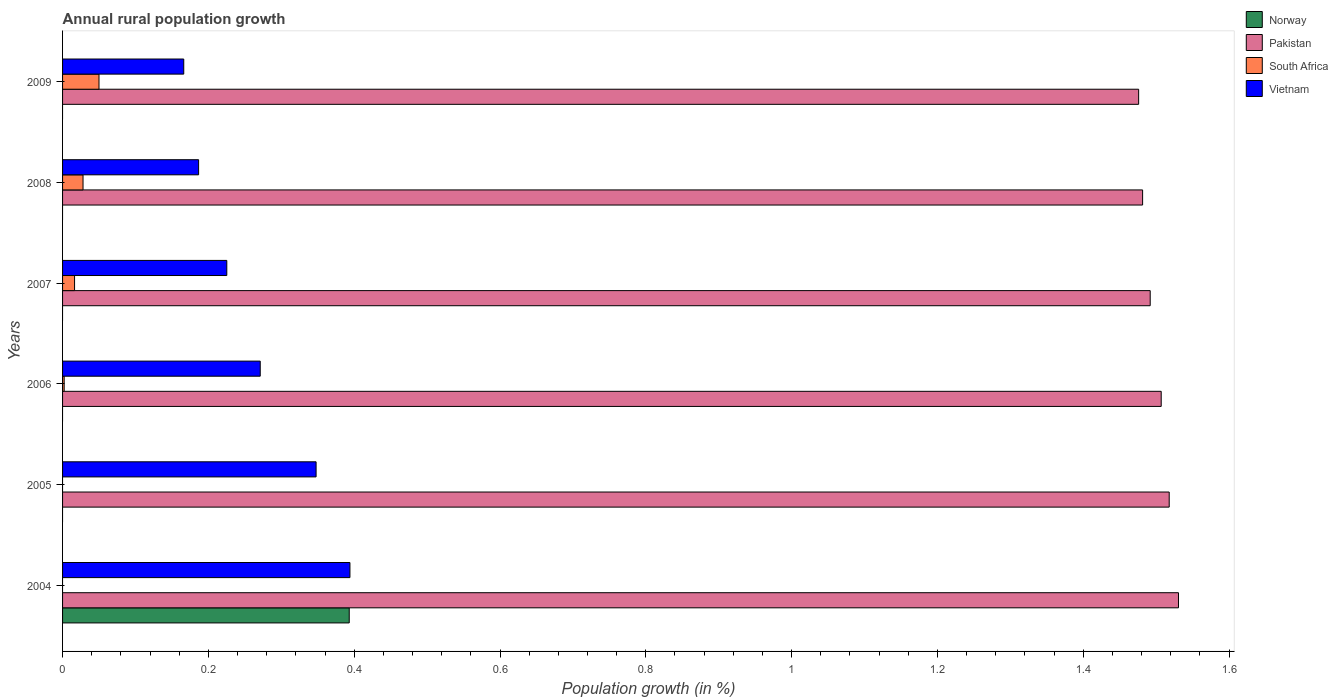How many different coloured bars are there?
Ensure brevity in your answer.  4. Are the number of bars per tick equal to the number of legend labels?
Offer a terse response. No. Are the number of bars on each tick of the Y-axis equal?
Your answer should be compact. No. How many bars are there on the 1st tick from the top?
Your answer should be very brief. 3. How many bars are there on the 6th tick from the bottom?
Your answer should be very brief. 3. What is the label of the 3rd group of bars from the top?
Your answer should be very brief. 2007. What is the percentage of rural population growth in Pakistan in 2006?
Keep it short and to the point. 1.51. Across all years, what is the maximum percentage of rural population growth in South Africa?
Provide a succinct answer. 0.05. In which year was the percentage of rural population growth in Norway maximum?
Offer a terse response. 2004. What is the total percentage of rural population growth in South Africa in the graph?
Ensure brevity in your answer.  0.1. What is the difference between the percentage of rural population growth in Vietnam in 2006 and that in 2009?
Provide a short and direct response. 0.1. What is the difference between the percentage of rural population growth in South Africa in 2006 and the percentage of rural population growth in Pakistan in 2009?
Give a very brief answer. -1.47. What is the average percentage of rural population growth in Vietnam per year?
Your answer should be compact. 0.27. In the year 2007, what is the difference between the percentage of rural population growth in Pakistan and percentage of rural population growth in Vietnam?
Your answer should be very brief. 1.27. In how many years, is the percentage of rural population growth in Pakistan greater than 1.36 %?
Keep it short and to the point. 6. What is the ratio of the percentage of rural population growth in Vietnam in 2005 to that in 2006?
Provide a short and direct response. 1.28. What is the difference between the highest and the second highest percentage of rural population growth in Vietnam?
Your response must be concise. 0.05. What is the difference between the highest and the lowest percentage of rural population growth in Pakistan?
Provide a short and direct response. 0.05. Is it the case that in every year, the sum of the percentage of rural population growth in Norway and percentage of rural population growth in Vietnam is greater than the sum of percentage of rural population growth in Pakistan and percentage of rural population growth in South Africa?
Provide a short and direct response. No. Is it the case that in every year, the sum of the percentage of rural population growth in Pakistan and percentage of rural population growth in Vietnam is greater than the percentage of rural population growth in South Africa?
Provide a succinct answer. Yes. How many bars are there?
Your answer should be very brief. 17. Are all the bars in the graph horizontal?
Ensure brevity in your answer.  Yes. How many years are there in the graph?
Offer a terse response. 6. What is the difference between two consecutive major ticks on the X-axis?
Your answer should be very brief. 0.2. Where does the legend appear in the graph?
Provide a succinct answer. Top right. What is the title of the graph?
Offer a terse response. Annual rural population growth. What is the label or title of the X-axis?
Offer a terse response. Population growth (in %). What is the Population growth (in %) in Norway in 2004?
Your response must be concise. 0.39. What is the Population growth (in %) in Pakistan in 2004?
Your answer should be very brief. 1.53. What is the Population growth (in %) of South Africa in 2004?
Keep it short and to the point. 0. What is the Population growth (in %) in Vietnam in 2004?
Your answer should be very brief. 0.39. What is the Population growth (in %) in Norway in 2005?
Offer a terse response. 0. What is the Population growth (in %) in Pakistan in 2005?
Ensure brevity in your answer.  1.52. What is the Population growth (in %) in Vietnam in 2005?
Make the answer very short. 0.35. What is the Population growth (in %) in Norway in 2006?
Make the answer very short. 0. What is the Population growth (in %) of Pakistan in 2006?
Make the answer very short. 1.51. What is the Population growth (in %) of South Africa in 2006?
Offer a terse response. 0. What is the Population growth (in %) in Vietnam in 2006?
Give a very brief answer. 0.27. What is the Population growth (in %) in Norway in 2007?
Your answer should be compact. 0. What is the Population growth (in %) in Pakistan in 2007?
Offer a terse response. 1.49. What is the Population growth (in %) of South Africa in 2007?
Your answer should be compact. 0.02. What is the Population growth (in %) of Vietnam in 2007?
Ensure brevity in your answer.  0.23. What is the Population growth (in %) of Norway in 2008?
Your response must be concise. 0. What is the Population growth (in %) of Pakistan in 2008?
Keep it short and to the point. 1.48. What is the Population growth (in %) of South Africa in 2008?
Provide a succinct answer. 0.03. What is the Population growth (in %) in Vietnam in 2008?
Your answer should be very brief. 0.19. What is the Population growth (in %) in Pakistan in 2009?
Provide a short and direct response. 1.48. What is the Population growth (in %) of South Africa in 2009?
Provide a succinct answer. 0.05. What is the Population growth (in %) of Vietnam in 2009?
Ensure brevity in your answer.  0.17. Across all years, what is the maximum Population growth (in %) of Norway?
Your answer should be very brief. 0.39. Across all years, what is the maximum Population growth (in %) in Pakistan?
Your answer should be compact. 1.53. Across all years, what is the maximum Population growth (in %) in South Africa?
Ensure brevity in your answer.  0.05. Across all years, what is the maximum Population growth (in %) of Vietnam?
Your response must be concise. 0.39. Across all years, what is the minimum Population growth (in %) in Norway?
Make the answer very short. 0. Across all years, what is the minimum Population growth (in %) of Pakistan?
Keep it short and to the point. 1.48. Across all years, what is the minimum Population growth (in %) of Vietnam?
Give a very brief answer. 0.17. What is the total Population growth (in %) of Norway in the graph?
Your answer should be compact. 0.39. What is the total Population growth (in %) of Pakistan in the graph?
Provide a succinct answer. 9. What is the total Population growth (in %) of South Africa in the graph?
Your answer should be compact. 0.1. What is the total Population growth (in %) of Vietnam in the graph?
Offer a very short reply. 1.59. What is the difference between the Population growth (in %) of Pakistan in 2004 and that in 2005?
Make the answer very short. 0.01. What is the difference between the Population growth (in %) of Vietnam in 2004 and that in 2005?
Your response must be concise. 0.05. What is the difference between the Population growth (in %) of Pakistan in 2004 and that in 2006?
Ensure brevity in your answer.  0.02. What is the difference between the Population growth (in %) of Vietnam in 2004 and that in 2006?
Your answer should be compact. 0.12. What is the difference between the Population growth (in %) in Pakistan in 2004 and that in 2007?
Your answer should be very brief. 0.04. What is the difference between the Population growth (in %) of Vietnam in 2004 and that in 2007?
Provide a succinct answer. 0.17. What is the difference between the Population growth (in %) in Pakistan in 2004 and that in 2008?
Provide a succinct answer. 0.05. What is the difference between the Population growth (in %) in Vietnam in 2004 and that in 2008?
Your response must be concise. 0.21. What is the difference between the Population growth (in %) of Pakistan in 2004 and that in 2009?
Keep it short and to the point. 0.05. What is the difference between the Population growth (in %) in Vietnam in 2004 and that in 2009?
Provide a succinct answer. 0.23. What is the difference between the Population growth (in %) in Pakistan in 2005 and that in 2006?
Keep it short and to the point. 0.01. What is the difference between the Population growth (in %) of Vietnam in 2005 and that in 2006?
Your answer should be very brief. 0.08. What is the difference between the Population growth (in %) in Pakistan in 2005 and that in 2007?
Provide a short and direct response. 0.03. What is the difference between the Population growth (in %) of Vietnam in 2005 and that in 2007?
Ensure brevity in your answer.  0.12. What is the difference between the Population growth (in %) of Pakistan in 2005 and that in 2008?
Ensure brevity in your answer.  0.04. What is the difference between the Population growth (in %) in Vietnam in 2005 and that in 2008?
Your response must be concise. 0.16. What is the difference between the Population growth (in %) of Pakistan in 2005 and that in 2009?
Offer a very short reply. 0.04. What is the difference between the Population growth (in %) in Vietnam in 2005 and that in 2009?
Offer a very short reply. 0.18. What is the difference between the Population growth (in %) of Pakistan in 2006 and that in 2007?
Give a very brief answer. 0.02. What is the difference between the Population growth (in %) in South Africa in 2006 and that in 2007?
Ensure brevity in your answer.  -0.01. What is the difference between the Population growth (in %) of Vietnam in 2006 and that in 2007?
Give a very brief answer. 0.05. What is the difference between the Population growth (in %) in Pakistan in 2006 and that in 2008?
Give a very brief answer. 0.03. What is the difference between the Population growth (in %) of South Africa in 2006 and that in 2008?
Your answer should be compact. -0.03. What is the difference between the Population growth (in %) in Vietnam in 2006 and that in 2008?
Your response must be concise. 0.08. What is the difference between the Population growth (in %) of Pakistan in 2006 and that in 2009?
Your answer should be very brief. 0.03. What is the difference between the Population growth (in %) of South Africa in 2006 and that in 2009?
Ensure brevity in your answer.  -0.05. What is the difference between the Population growth (in %) in Vietnam in 2006 and that in 2009?
Make the answer very short. 0.1. What is the difference between the Population growth (in %) of Pakistan in 2007 and that in 2008?
Offer a terse response. 0.01. What is the difference between the Population growth (in %) of South Africa in 2007 and that in 2008?
Provide a succinct answer. -0.01. What is the difference between the Population growth (in %) of Vietnam in 2007 and that in 2008?
Make the answer very short. 0.04. What is the difference between the Population growth (in %) in Pakistan in 2007 and that in 2009?
Your answer should be very brief. 0.02. What is the difference between the Population growth (in %) of South Africa in 2007 and that in 2009?
Your answer should be compact. -0.03. What is the difference between the Population growth (in %) of Vietnam in 2007 and that in 2009?
Ensure brevity in your answer.  0.06. What is the difference between the Population growth (in %) of Pakistan in 2008 and that in 2009?
Offer a terse response. 0.01. What is the difference between the Population growth (in %) in South Africa in 2008 and that in 2009?
Provide a succinct answer. -0.02. What is the difference between the Population growth (in %) of Vietnam in 2008 and that in 2009?
Make the answer very short. 0.02. What is the difference between the Population growth (in %) of Norway in 2004 and the Population growth (in %) of Pakistan in 2005?
Keep it short and to the point. -1.12. What is the difference between the Population growth (in %) of Norway in 2004 and the Population growth (in %) of Vietnam in 2005?
Your answer should be compact. 0.05. What is the difference between the Population growth (in %) of Pakistan in 2004 and the Population growth (in %) of Vietnam in 2005?
Ensure brevity in your answer.  1.18. What is the difference between the Population growth (in %) of Norway in 2004 and the Population growth (in %) of Pakistan in 2006?
Give a very brief answer. -1.11. What is the difference between the Population growth (in %) of Norway in 2004 and the Population growth (in %) of South Africa in 2006?
Ensure brevity in your answer.  0.39. What is the difference between the Population growth (in %) of Norway in 2004 and the Population growth (in %) of Vietnam in 2006?
Provide a succinct answer. 0.12. What is the difference between the Population growth (in %) of Pakistan in 2004 and the Population growth (in %) of South Africa in 2006?
Make the answer very short. 1.53. What is the difference between the Population growth (in %) in Pakistan in 2004 and the Population growth (in %) in Vietnam in 2006?
Your answer should be very brief. 1.26. What is the difference between the Population growth (in %) of Norway in 2004 and the Population growth (in %) of Pakistan in 2007?
Offer a terse response. -1.1. What is the difference between the Population growth (in %) in Norway in 2004 and the Population growth (in %) in South Africa in 2007?
Offer a very short reply. 0.38. What is the difference between the Population growth (in %) in Norway in 2004 and the Population growth (in %) in Vietnam in 2007?
Offer a very short reply. 0.17. What is the difference between the Population growth (in %) of Pakistan in 2004 and the Population growth (in %) of South Africa in 2007?
Ensure brevity in your answer.  1.51. What is the difference between the Population growth (in %) in Pakistan in 2004 and the Population growth (in %) in Vietnam in 2007?
Ensure brevity in your answer.  1.31. What is the difference between the Population growth (in %) in Norway in 2004 and the Population growth (in %) in Pakistan in 2008?
Offer a terse response. -1.09. What is the difference between the Population growth (in %) in Norway in 2004 and the Population growth (in %) in South Africa in 2008?
Your answer should be compact. 0.37. What is the difference between the Population growth (in %) of Norway in 2004 and the Population growth (in %) of Vietnam in 2008?
Offer a terse response. 0.21. What is the difference between the Population growth (in %) of Pakistan in 2004 and the Population growth (in %) of South Africa in 2008?
Make the answer very short. 1.5. What is the difference between the Population growth (in %) of Pakistan in 2004 and the Population growth (in %) of Vietnam in 2008?
Your answer should be compact. 1.34. What is the difference between the Population growth (in %) in Norway in 2004 and the Population growth (in %) in Pakistan in 2009?
Make the answer very short. -1.08. What is the difference between the Population growth (in %) in Norway in 2004 and the Population growth (in %) in South Africa in 2009?
Provide a short and direct response. 0.34. What is the difference between the Population growth (in %) of Norway in 2004 and the Population growth (in %) of Vietnam in 2009?
Provide a short and direct response. 0.23. What is the difference between the Population growth (in %) in Pakistan in 2004 and the Population growth (in %) in South Africa in 2009?
Your answer should be very brief. 1.48. What is the difference between the Population growth (in %) in Pakistan in 2004 and the Population growth (in %) in Vietnam in 2009?
Ensure brevity in your answer.  1.36. What is the difference between the Population growth (in %) of Pakistan in 2005 and the Population growth (in %) of South Africa in 2006?
Provide a short and direct response. 1.52. What is the difference between the Population growth (in %) in Pakistan in 2005 and the Population growth (in %) in Vietnam in 2006?
Make the answer very short. 1.25. What is the difference between the Population growth (in %) of Pakistan in 2005 and the Population growth (in %) of South Africa in 2007?
Offer a very short reply. 1.5. What is the difference between the Population growth (in %) of Pakistan in 2005 and the Population growth (in %) of Vietnam in 2007?
Give a very brief answer. 1.29. What is the difference between the Population growth (in %) of Pakistan in 2005 and the Population growth (in %) of South Africa in 2008?
Give a very brief answer. 1.49. What is the difference between the Population growth (in %) of Pakistan in 2005 and the Population growth (in %) of Vietnam in 2008?
Ensure brevity in your answer.  1.33. What is the difference between the Population growth (in %) in Pakistan in 2005 and the Population growth (in %) in South Africa in 2009?
Your answer should be very brief. 1.47. What is the difference between the Population growth (in %) in Pakistan in 2005 and the Population growth (in %) in Vietnam in 2009?
Keep it short and to the point. 1.35. What is the difference between the Population growth (in %) in Pakistan in 2006 and the Population growth (in %) in South Africa in 2007?
Your answer should be compact. 1.49. What is the difference between the Population growth (in %) in Pakistan in 2006 and the Population growth (in %) in Vietnam in 2007?
Ensure brevity in your answer.  1.28. What is the difference between the Population growth (in %) in South Africa in 2006 and the Population growth (in %) in Vietnam in 2007?
Give a very brief answer. -0.22. What is the difference between the Population growth (in %) of Pakistan in 2006 and the Population growth (in %) of South Africa in 2008?
Give a very brief answer. 1.48. What is the difference between the Population growth (in %) in Pakistan in 2006 and the Population growth (in %) in Vietnam in 2008?
Make the answer very short. 1.32. What is the difference between the Population growth (in %) in South Africa in 2006 and the Population growth (in %) in Vietnam in 2008?
Your answer should be very brief. -0.18. What is the difference between the Population growth (in %) of Pakistan in 2006 and the Population growth (in %) of South Africa in 2009?
Your answer should be compact. 1.46. What is the difference between the Population growth (in %) in Pakistan in 2006 and the Population growth (in %) in Vietnam in 2009?
Make the answer very short. 1.34. What is the difference between the Population growth (in %) of South Africa in 2006 and the Population growth (in %) of Vietnam in 2009?
Your answer should be compact. -0.16. What is the difference between the Population growth (in %) of Pakistan in 2007 and the Population growth (in %) of South Africa in 2008?
Your response must be concise. 1.46. What is the difference between the Population growth (in %) of Pakistan in 2007 and the Population growth (in %) of Vietnam in 2008?
Provide a short and direct response. 1.31. What is the difference between the Population growth (in %) of South Africa in 2007 and the Population growth (in %) of Vietnam in 2008?
Your answer should be compact. -0.17. What is the difference between the Population growth (in %) in Pakistan in 2007 and the Population growth (in %) in South Africa in 2009?
Your answer should be compact. 1.44. What is the difference between the Population growth (in %) in Pakistan in 2007 and the Population growth (in %) in Vietnam in 2009?
Your answer should be compact. 1.33. What is the difference between the Population growth (in %) of South Africa in 2007 and the Population growth (in %) of Vietnam in 2009?
Offer a terse response. -0.15. What is the difference between the Population growth (in %) of Pakistan in 2008 and the Population growth (in %) of South Africa in 2009?
Offer a very short reply. 1.43. What is the difference between the Population growth (in %) in Pakistan in 2008 and the Population growth (in %) in Vietnam in 2009?
Keep it short and to the point. 1.32. What is the difference between the Population growth (in %) in South Africa in 2008 and the Population growth (in %) in Vietnam in 2009?
Give a very brief answer. -0.14. What is the average Population growth (in %) in Norway per year?
Keep it short and to the point. 0.07. What is the average Population growth (in %) of Pakistan per year?
Provide a short and direct response. 1.5. What is the average Population growth (in %) in South Africa per year?
Ensure brevity in your answer.  0.02. What is the average Population growth (in %) in Vietnam per year?
Ensure brevity in your answer.  0.27. In the year 2004, what is the difference between the Population growth (in %) in Norway and Population growth (in %) in Pakistan?
Your answer should be very brief. -1.14. In the year 2004, what is the difference between the Population growth (in %) of Norway and Population growth (in %) of Vietnam?
Your response must be concise. -0. In the year 2004, what is the difference between the Population growth (in %) of Pakistan and Population growth (in %) of Vietnam?
Give a very brief answer. 1.14. In the year 2005, what is the difference between the Population growth (in %) in Pakistan and Population growth (in %) in Vietnam?
Give a very brief answer. 1.17. In the year 2006, what is the difference between the Population growth (in %) in Pakistan and Population growth (in %) in South Africa?
Offer a very short reply. 1.5. In the year 2006, what is the difference between the Population growth (in %) of Pakistan and Population growth (in %) of Vietnam?
Your answer should be very brief. 1.24. In the year 2006, what is the difference between the Population growth (in %) of South Africa and Population growth (in %) of Vietnam?
Provide a succinct answer. -0.27. In the year 2007, what is the difference between the Population growth (in %) in Pakistan and Population growth (in %) in South Africa?
Your answer should be compact. 1.48. In the year 2007, what is the difference between the Population growth (in %) of Pakistan and Population growth (in %) of Vietnam?
Offer a terse response. 1.27. In the year 2007, what is the difference between the Population growth (in %) of South Africa and Population growth (in %) of Vietnam?
Offer a terse response. -0.21. In the year 2008, what is the difference between the Population growth (in %) of Pakistan and Population growth (in %) of South Africa?
Give a very brief answer. 1.45. In the year 2008, what is the difference between the Population growth (in %) of Pakistan and Population growth (in %) of Vietnam?
Give a very brief answer. 1.29. In the year 2008, what is the difference between the Population growth (in %) in South Africa and Population growth (in %) in Vietnam?
Provide a succinct answer. -0.16. In the year 2009, what is the difference between the Population growth (in %) of Pakistan and Population growth (in %) of South Africa?
Give a very brief answer. 1.43. In the year 2009, what is the difference between the Population growth (in %) in Pakistan and Population growth (in %) in Vietnam?
Ensure brevity in your answer.  1.31. In the year 2009, what is the difference between the Population growth (in %) of South Africa and Population growth (in %) of Vietnam?
Make the answer very short. -0.12. What is the ratio of the Population growth (in %) in Pakistan in 2004 to that in 2005?
Provide a short and direct response. 1.01. What is the ratio of the Population growth (in %) in Vietnam in 2004 to that in 2005?
Provide a short and direct response. 1.13. What is the ratio of the Population growth (in %) in Pakistan in 2004 to that in 2006?
Your response must be concise. 1.02. What is the ratio of the Population growth (in %) of Vietnam in 2004 to that in 2006?
Make the answer very short. 1.45. What is the ratio of the Population growth (in %) of Vietnam in 2004 to that in 2007?
Offer a terse response. 1.75. What is the ratio of the Population growth (in %) of Pakistan in 2004 to that in 2008?
Your answer should be very brief. 1.03. What is the ratio of the Population growth (in %) of Vietnam in 2004 to that in 2008?
Provide a short and direct response. 2.11. What is the ratio of the Population growth (in %) in Vietnam in 2004 to that in 2009?
Your answer should be very brief. 2.37. What is the ratio of the Population growth (in %) of Pakistan in 2005 to that in 2006?
Your answer should be very brief. 1.01. What is the ratio of the Population growth (in %) in Vietnam in 2005 to that in 2006?
Ensure brevity in your answer.  1.28. What is the ratio of the Population growth (in %) of Pakistan in 2005 to that in 2007?
Provide a short and direct response. 1.02. What is the ratio of the Population growth (in %) in Vietnam in 2005 to that in 2007?
Ensure brevity in your answer.  1.54. What is the ratio of the Population growth (in %) in Pakistan in 2005 to that in 2008?
Your response must be concise. 1.02. What is the ratio of the Population growth (in %) of Vietnam in 2005 to that in 2008?
Give a very brief answer. 1.86. What is the ratio of the Population growth (in %) in Pakistan in 2005 to that in 2009?
Offer a very short reply. 1.03. What is the ratio of the Population growth (in %) in Vietnam in 2005 to that in 2009?
Keep it short and to the point. 2.09. What is the ratio of the Population growth (in %) in South Africa in 2006 to that in 2007?
Offer a very short reply. 0.13. What is the ratio of the Population growth (in %) of Vietnam in 2006 to that in 2007?
Your answer should be very brief. 1.2. What is the ratio of the Population growth (in %) in Pakistan in 2006 to that in 2008?
Your answer should be very brief. 1.02. What is the ratio of the Population growth (in %) in South Africa in 2006 to that in 2008?
Provide a short and direct response. 0.08. What is the ratio of the Population growth (in %) of Vietnam in 2006 to that in 2008?
Provide a short and direct response. 1.45. What is the ratio of the Population growth (in %) in South Africa in 2006 to that in 2009?
Make the answer very short. 0.04. What is the ratio of the Population growth (in %) in Vietnam in 2006 to that in 2009?
Give a very brief answer. 1.63. What is the ratio of the Population growth (in %) in South Africa in 2007 to that in 2008?
Make the answer very short. 0.59. What is the ratio of the Population growth (in %) in Vietnam in 2007 to that in 2008?
Keep it short and to the point. 1.21. What is the ratio of the Population growth (in %) in Pakistan in 2007 to that in 2009?
Your answer should be very brief. 1.01. What is the ratio of the Population growth (in %) of South Africa in 2007 to that in 2009?
Provide a short and direct response. 0.33. What is the ratio of the Population growth (in %) in Vietnam in 2007 to that in 2009?
Ensure brevity in your answer.  1.36. What is the ratio of the Population growth (in %) of South Africa in 2008 to that in 2009?
Provide a succinct answer. 0.56. What is the ratio of the Population growth (in %) in Vietnam in 2008 to that in 2009?
Make the answer very short. 1.12. What is the difference between the highest and the second highest Population growth (in %) of Pakistan?
Keep it short and to the point. 0.01. What is the difference between the highest and the second highest Population growth (in %) of South Africa?
Keep it short and to the point. 0.02. What is the difference between the highest and the second highest Population growth (in %) of Vietnam?
Ensure brevity in your answer.  0.05. What is the difference between the highest and the lowest Population growth (in %) in Norway?
Offer a terse response. 0.39. What is the difference between the highest and the lowest Population growth (in %) in Pakistan?
Offer a terse response. 0.05. What is the difference between the highest and the lowest Population growth (in %) of Vietnam?
Offer a very short reply. 0.23. 